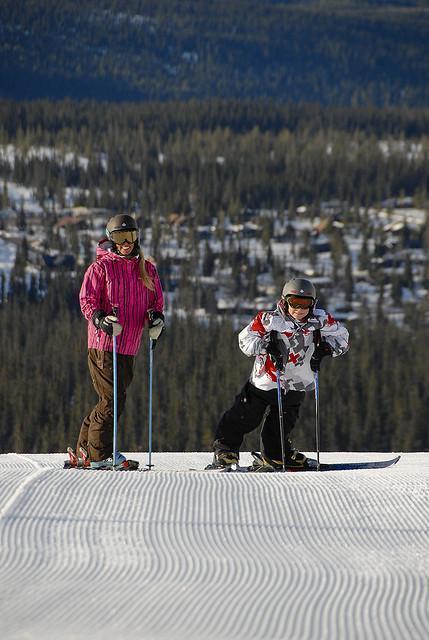How many people are there?
Give a very brief answer. 2. How many silver cars are in the image?
Give a very brief answer. 0. 